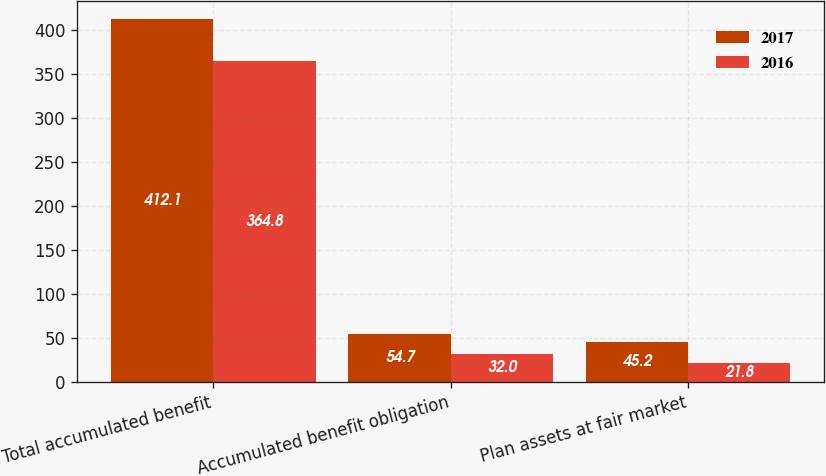Convert chart to OTSL. <chart><loc_0><loc_0><loc_500><loc_500><stacked_bar_chart><ecel><fcel>Total accumulated benefit<fcel>Accumulated benefit obligation<fcel>Plan assets at fair market<nl><fcel>2017<fcel>412.1<fcel>54.7<fcel>45.2<nl><fcel>2016<fcel>364.8<fcel>32<fcel>21.8<nl></chart> 